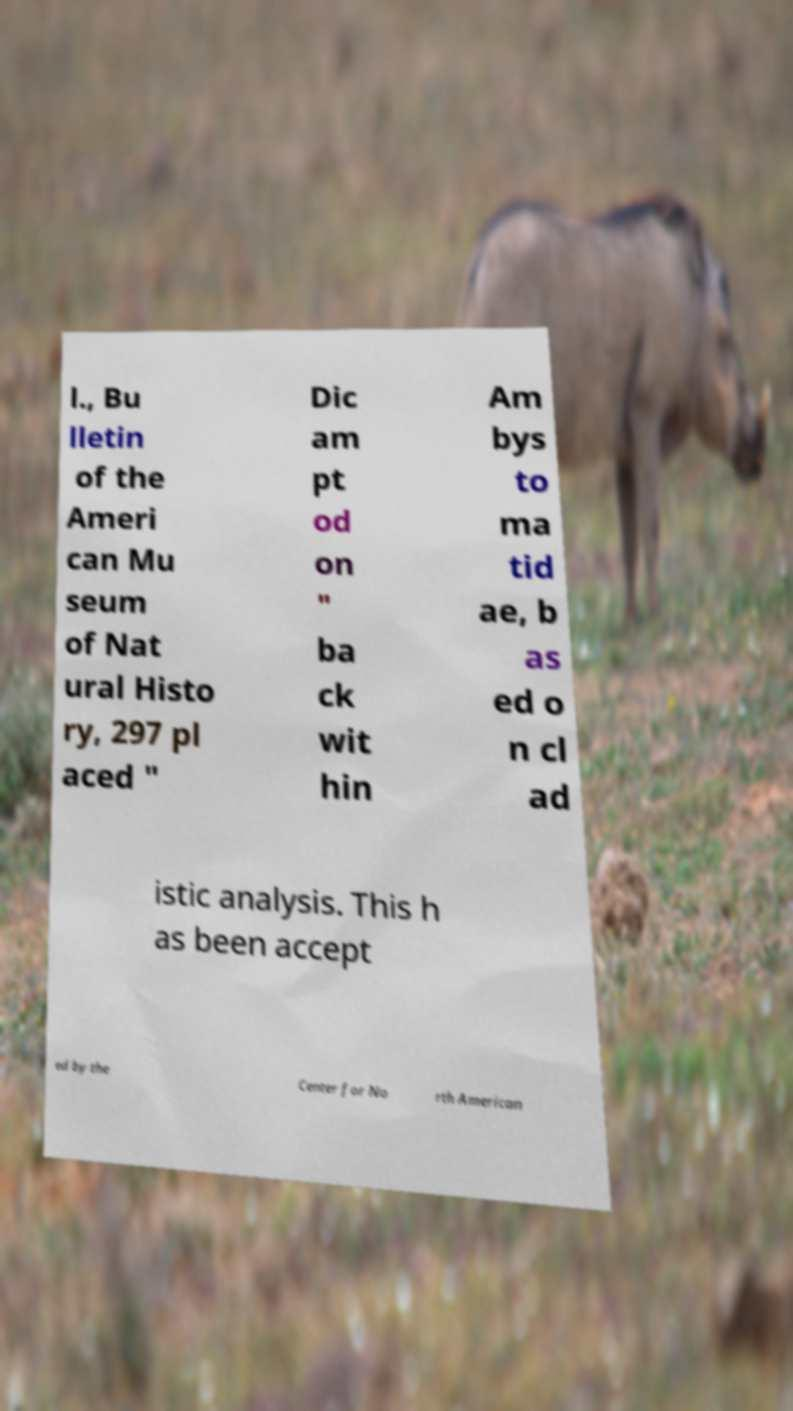Please identify and transcribe the text found in this image. l., Bu lletin of the Ameri can Mu seum of Nat ural Histo ry, 297 pl aced " Dic am pt od on " ba ck wit hin Am bys to ma tid ae, b as ed o n cl ad istic analysis. This h as been accept ed by the Center for No rth American 